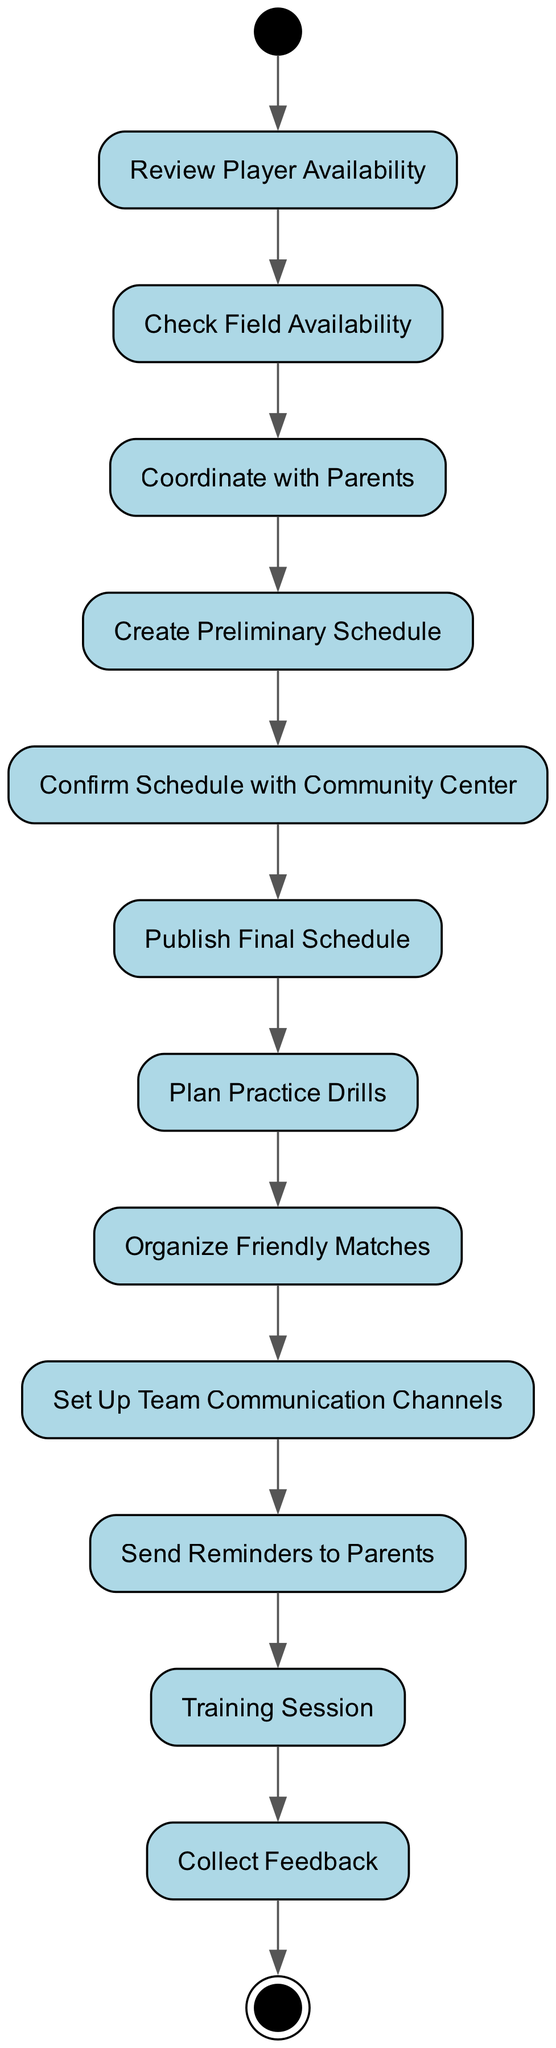What is the first activity in the diagram? The diagram starts with the "Start" activity, which is the initial node from which all other activities proceed.
Answer: Start How many total activities are there in the diagram? By counting the individual activity nodes in the diagram, there are 13 activities listed.
Answer: 13 What activity follows "Coordinate with Parents"? After "Coordinate with Parents," the next activity is "Create Preliminary Schedule," indicating the direct flow in the sequence of activities.
Answer: Create Preliminary Schedule What is the last activity before reaching the final node? The last activity before the "End" node is "Collect Feedback," which shows the conclusion of the training session process.
Answer: Collect Feedback Which activity involves parents directly? The activity that involves parents directly is "Coordinate with Parents," indicating the step where communication with parents happens.
Answer: Coordinate with Parents How many transitions are there in the diagram? By counting all the directed edges between the activities, there are 12 transitions present in the diagram.
Answer: 12 What is the purpose of the "Set Up Team Communication Channels" activity? This activity is designed to establish ways for the team members and parents to stay informed and connected, facilitating communication related to sessions.
Answer: To facilitate communication How many activities are planned after the "Publish Final Schedule"? After "Publish Final Schedule," there are three activities planned: "Plan Practice Drills," "Organize Friendly Matches," and "Set Up Team Communication Channels."
Answer: Three What activity comes directly before the "Training Session"? The activity that comes directly before the "Training Session" is "Send Reminders to Parents," ensuring that everyone is notified prior to the session.
Answer: Send Reminders to Parents 